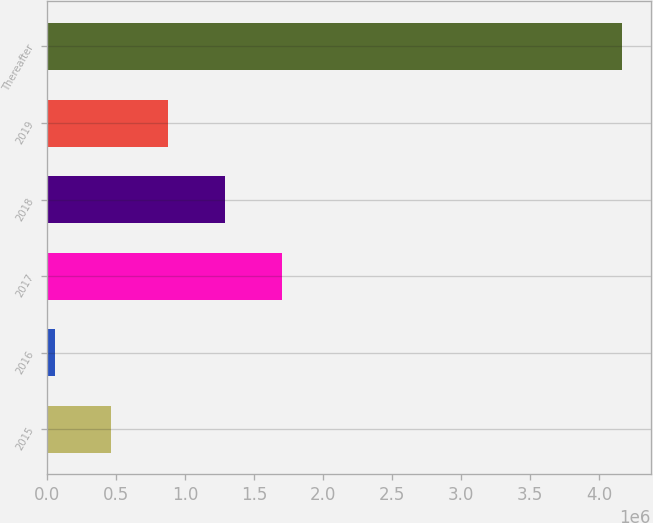Convert chart. <chart><loc_0><loc_0><loc_500><loc_500><bar_chart><fcel>2015<fcel>2016<fcel>2017<fcel>2018<fcel>2019<fcel>Thereafter<nl><fcel>464679<fcel>53353<fcel>1.69866e+06<fcel>1.28733e+06<fcel>876004<fcel>4.16661e+06<nl></chart> 